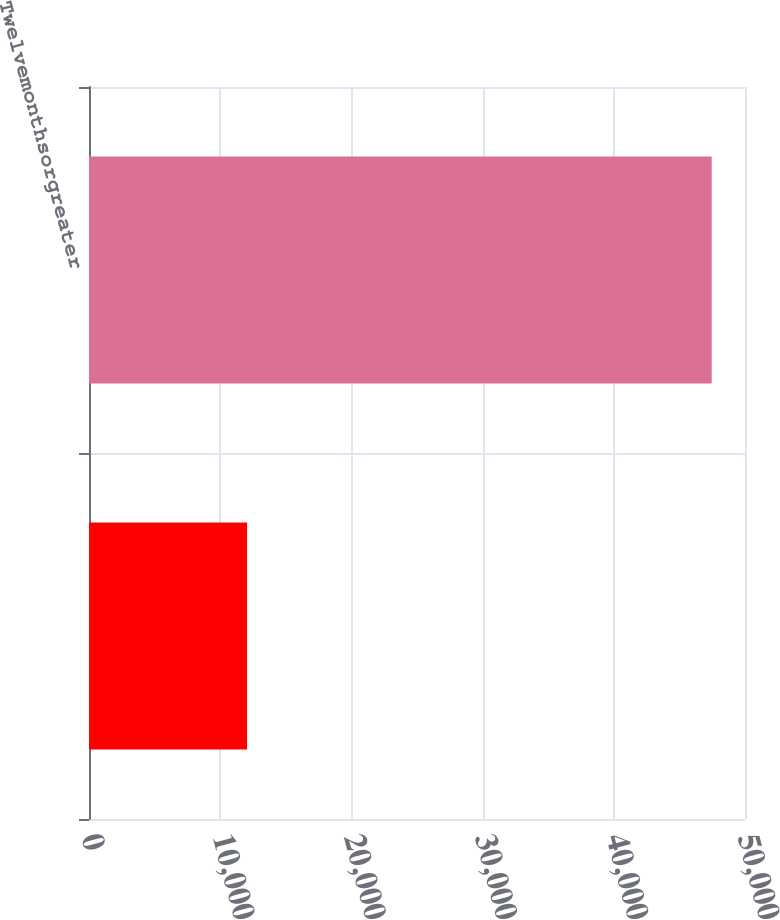Convert chart. <chart><loc_0><loc_0><loc_500><loc_500><bar_chart><ecel><fcel>Twelvemonthsorgreater<nl><fcel>12049<fcel>47462<nl></chart> 